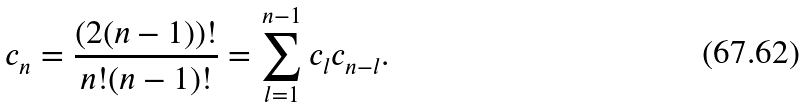Convert formula to latex. <formula><loc_0><loc_0><loc_500><loc_500>c _ { n } = \frac { ( 2 ( n - 1 ) ) ! } { n ! ( n - 1 ) ! } = \sum _ { l = 1 } ^ { n - 1 } c _ { l } c _ { n - l } .</formula> 